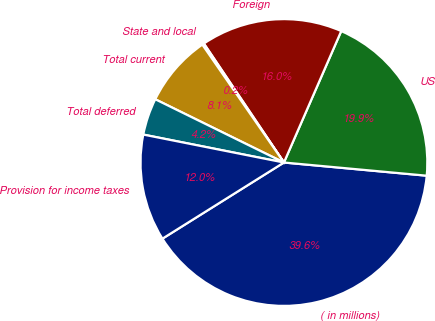Convert chart. <chart><loc_0><loc_0><loc_500><loc_500><pie_chart><fcel>( in millions)<fcel>US<fcel>Foreign<fcel>State and local<fcel>Total current<fcel>Total deferred<fcel>Provision for income taxes<nl><fcel>39.62%<fcel>19.92%<fcel>15.97%<fcel>0.21%<fcel>8.09%<fcel>4.15%<fcel>12.03%<nl></chart> 